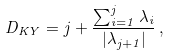<formula> <loc_0><loc_0><loc_500><loc_500>D _ { K Y } = j + \frac { \sum _ { i = 1 } ^ { j } \lambda _ { i } } { | \lambda _ { j + 1 } | } \, ,</formula> 